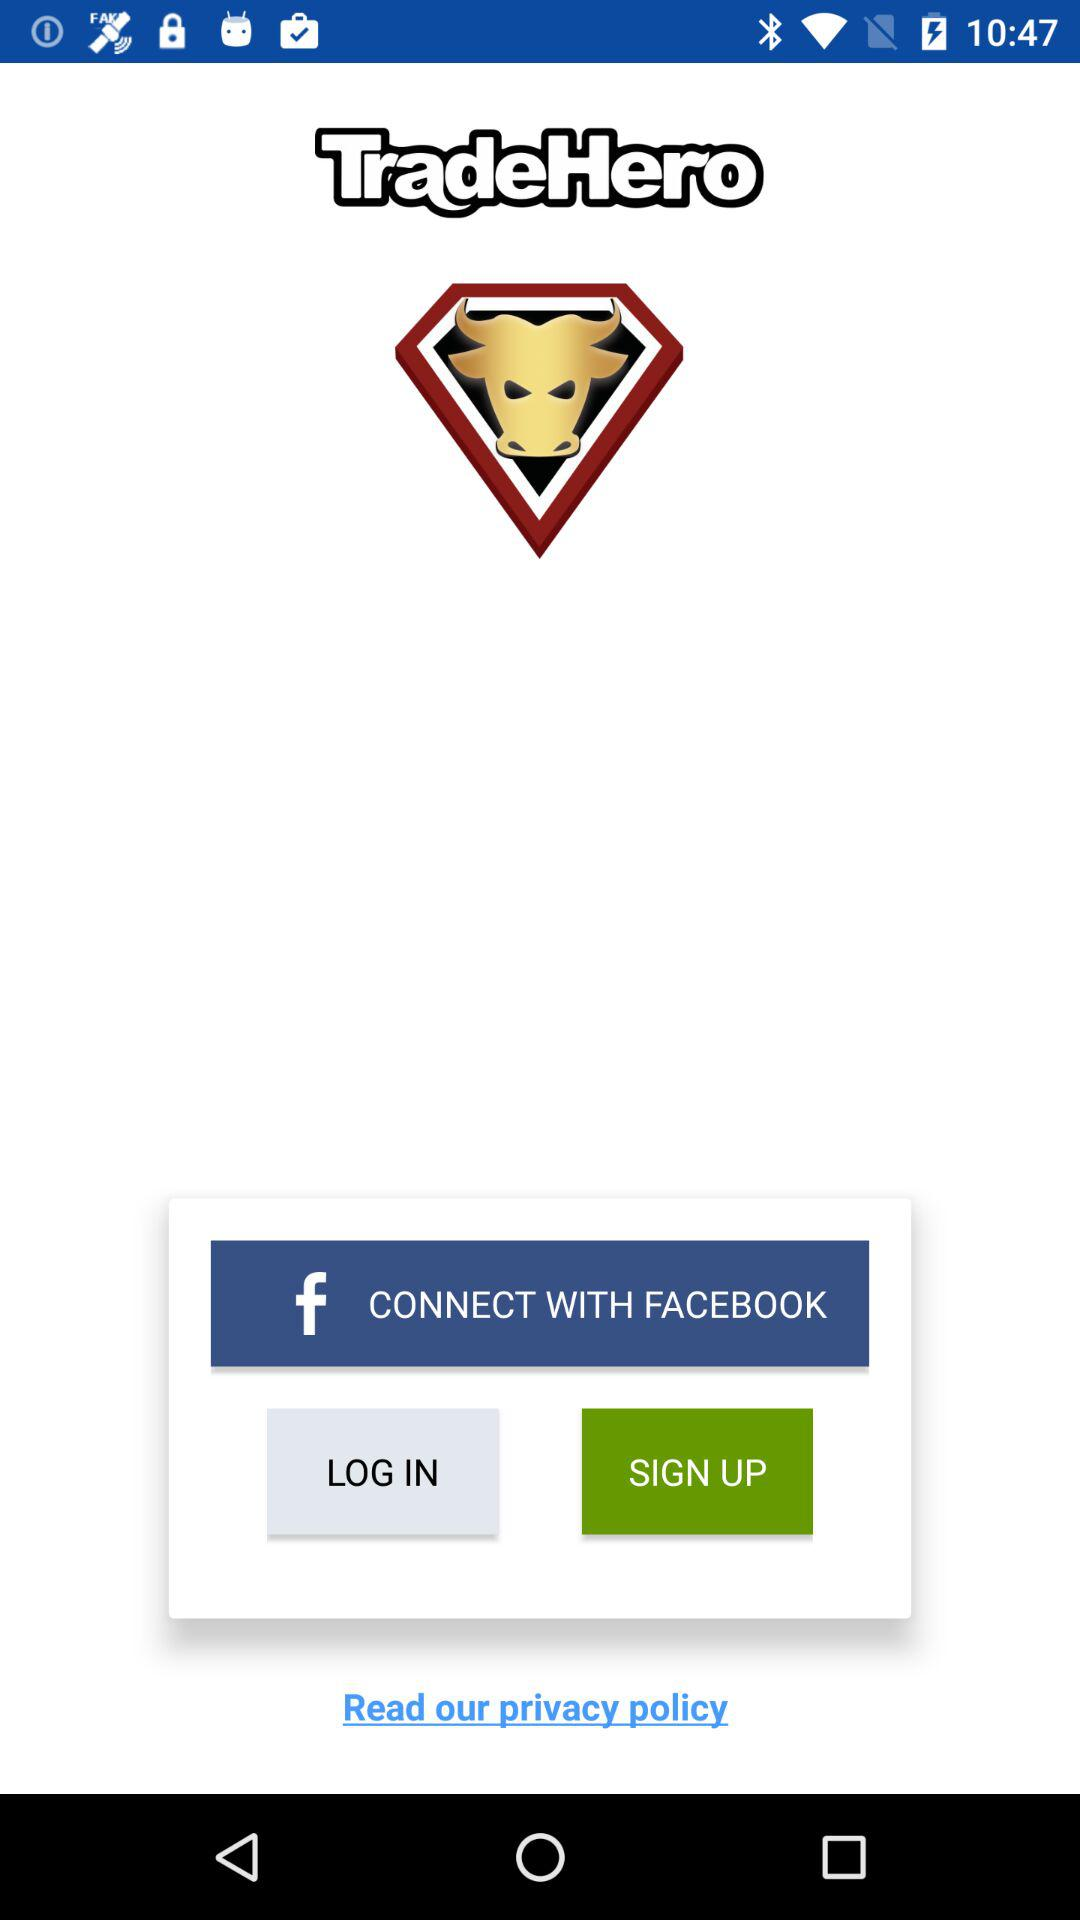What option is given for connecting? The given option for connecting is "FACEBOOK". 